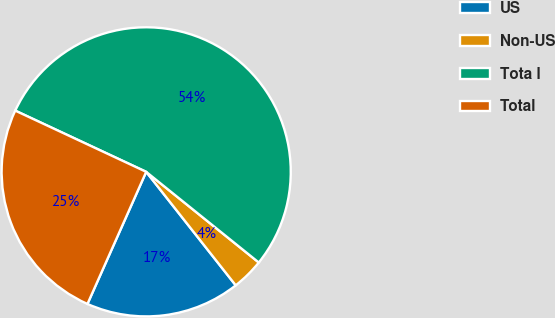Convert chart to OTSL. <chart><loc_0><loc_0><loc_500><loc_500><pie_chart><fcel>US<fcel>Non-US<fcel>Tota l<fcel>Total<nl><fcel>17.29%<fcel>3.58%<fcel>53.83%<fcel>25.3%<nl></chart> 